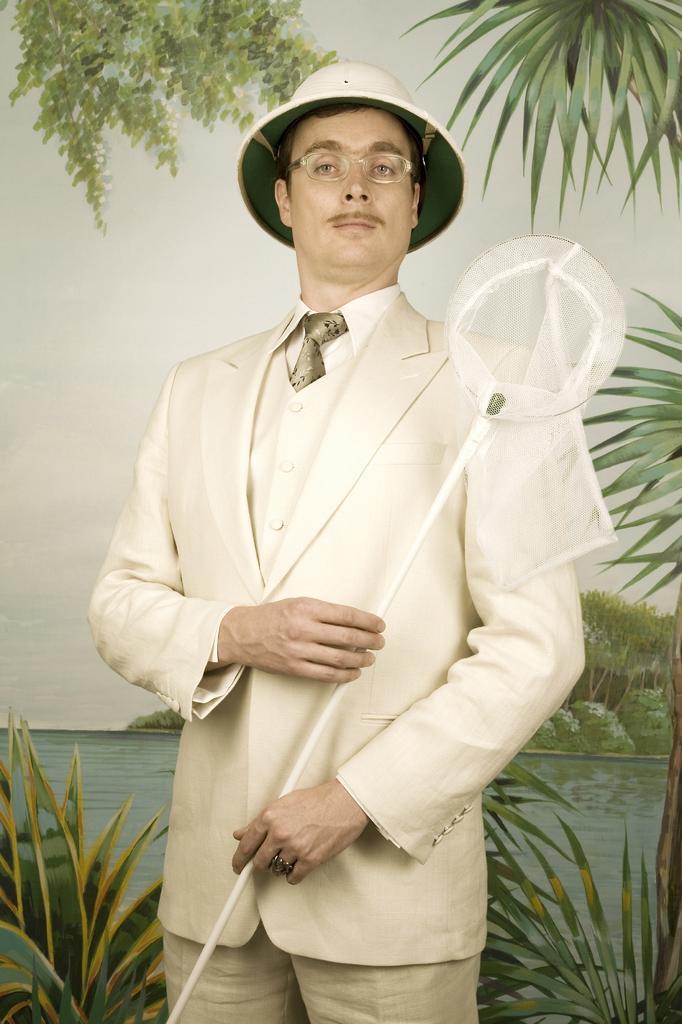How would you summarize this image in a sentence or two? In the background we can see the sky, water, trees. In this picture we can see the plants. We can see a man wearing a hat, spectacles. He is holding a white object in his hands. 